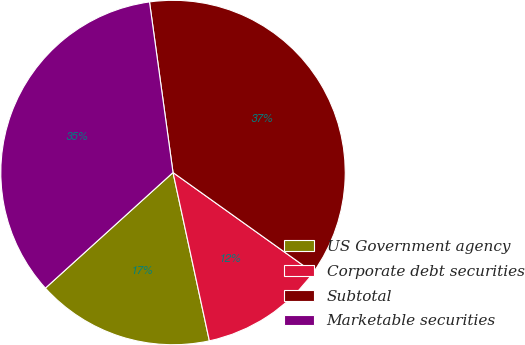Convert chart to OTSL. <chart><loc_0><loc_0><loc_500><loc_500><pie_chart><fcel>US Government agency<fcel>Corporate debt securities<fcel>Subtotal<fcel>Marketable securities<nl><fcel>16.67%<fcel>11.75%<fcel>37.04%<fcel>34.53%<nl></chart> 